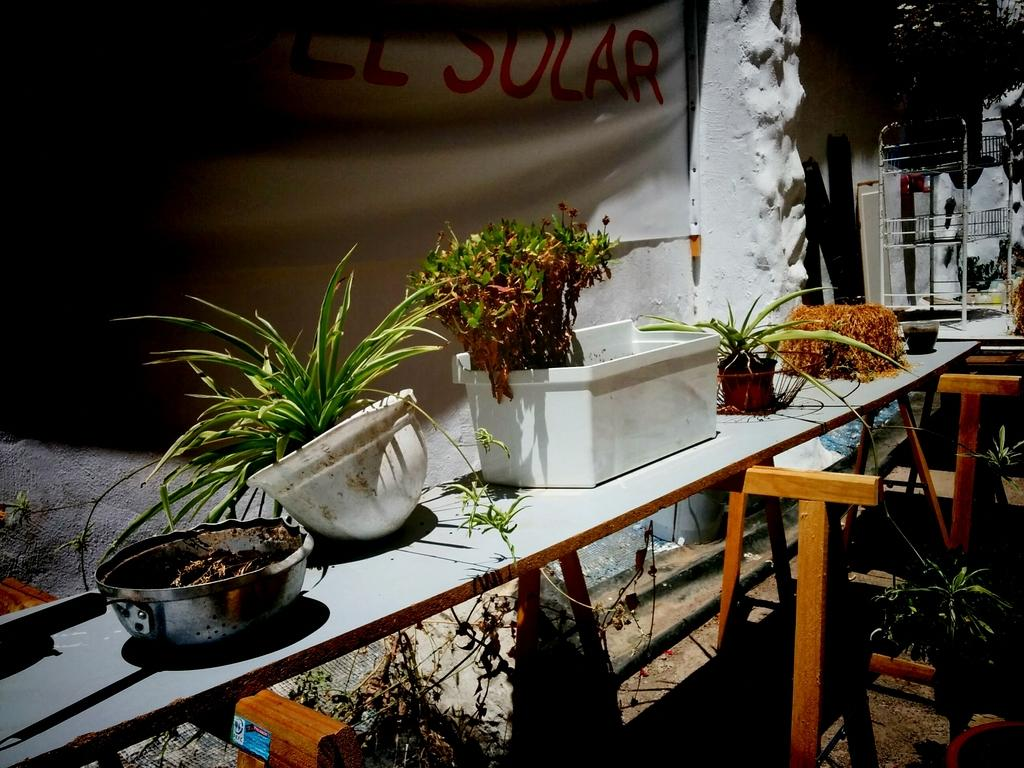What is the main piece of furniture in the image? There is a table in the image. What is placed on the table? There are plants on the table. What can be seen in the background of the image? There is a banner visible in the background. What type of copper material is used to make the driving wheel in the image? There is no copper material or driving wheel present in the image. 